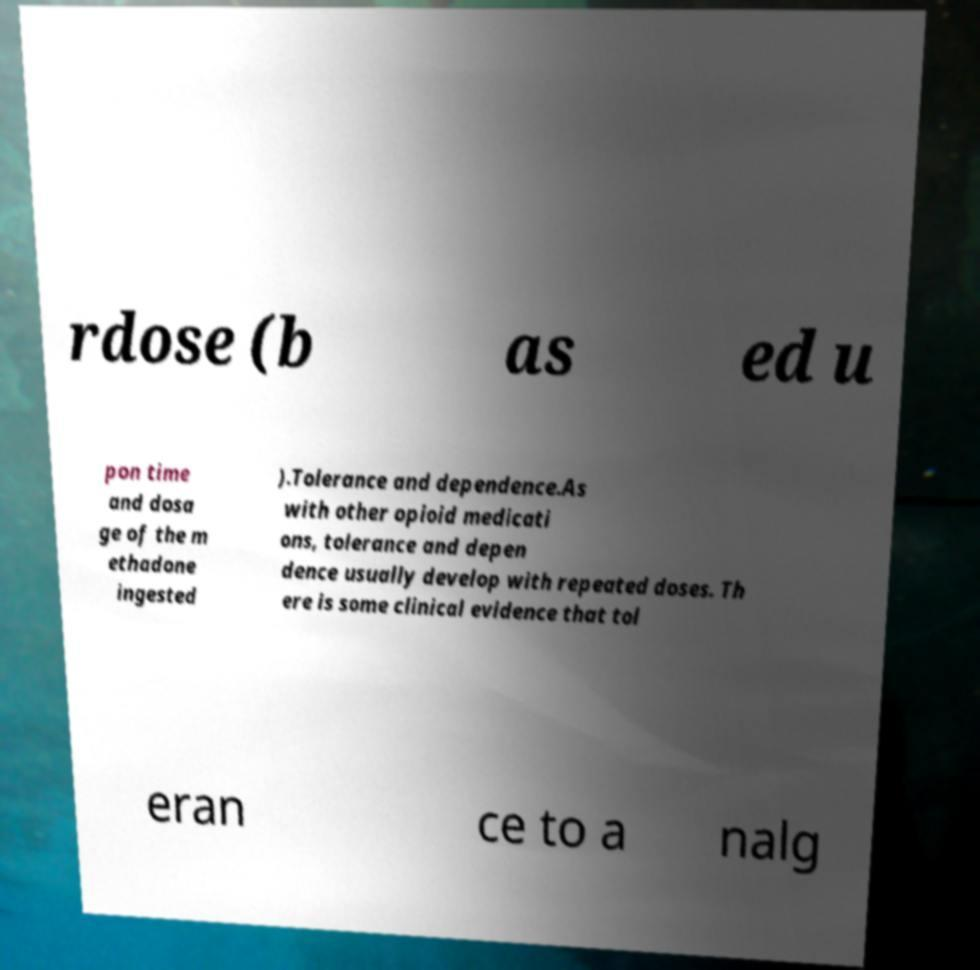For documentation purposes, I need the text within this image transcribed. Could you provide that? rdose (b as ed u pon time and dosa ge of the m ethadone ingested ).Tolerance and dependence.As with other opioid medicati ons, tolerance and depen dence usually develop with repeated doses. Th ere is some clinical evidence that tol eran ce to a nalg 